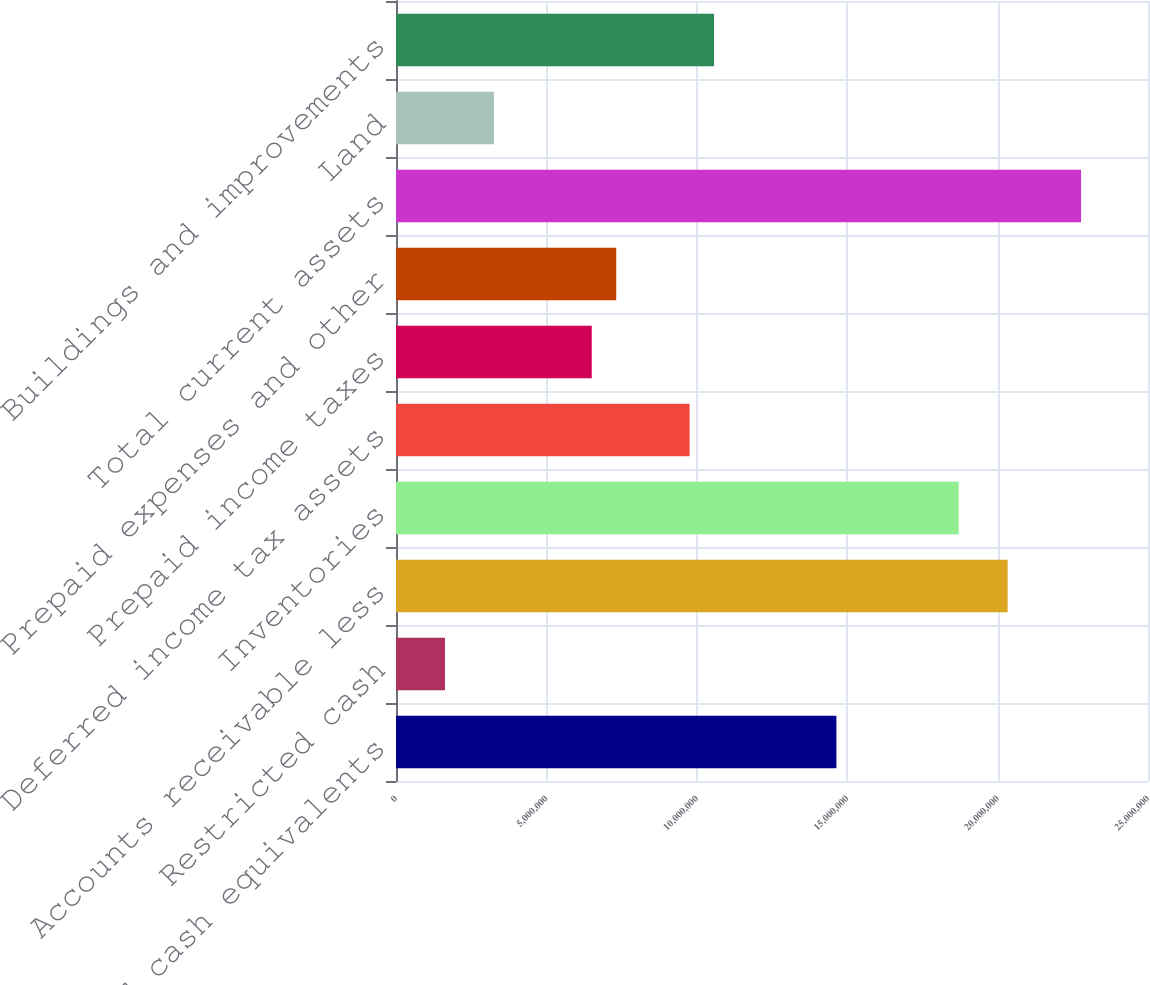Convert chart to OTSL. <chart><loc_0><loc_0><loc_500><loc_500><bar_chart><fcel>Cash and cash equivalents<fcel>Restricted cash<fcel>Accounts receivable less<fcel>Inventories<fcel>Deferred income tax assets<fcel>Prepaid income taxes<fcel>Prepaid expenses and other<fcel>Total current assets<fcel>Land<fcel>Buildings and improvements<nl><fcel>1.46412e+07<fcel>1.62807e+06<fcel>2.03344e+07<fcel>1.87078e+07<fcel>9.76127e+06<fcel>6.50799e+06<fcel>7.32131e+06<fcel>2.27744e+07<fcel>3.25471e+06<fcel>1.05746e+07<nl></chart> 